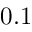<formula> <loc_0><loc_0><loc_500><loc_500>0 . 1</formula> 